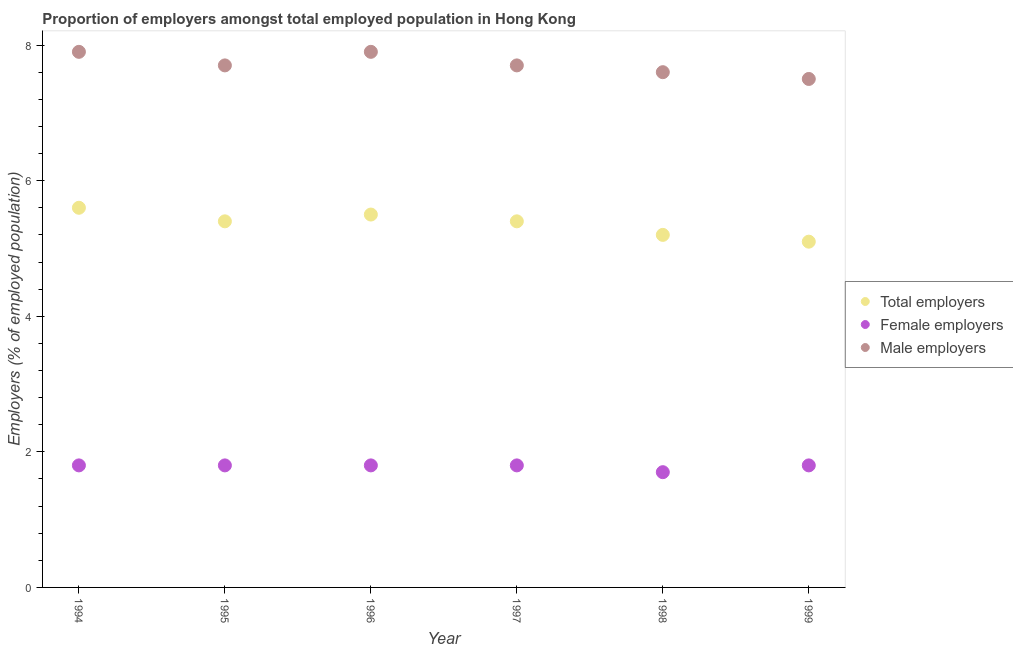How many different coloured dotlines are there?
Make the answer very short. 3. Is the number of dotlines equal to the number of legend labels?
Give a very brief answer. Yes. What is the percentage of male employers in 1997?
Your response must be concise. 7.7. Across all years, what is the maximum percentage of total employers?
Your answer should be compact. 5.6. What is the total percentage of female employers in the graph?
Give a very brief answer. 10.7. What is the difference between the percentage of total employers in 1995 and that in 1996?
Your response must be concise. -0.1. What is the difference between the percentage of male employers in 1994 and the percentage of total employers in 1996?
Your answer should be very brief. 2.4. What is the average percentage of total employers per year?
Give a very brief answer. 5.37. In the year 1994, what is the difference between the percentage of female employers and percentage of total employers?
Offer a very short reply. -3.8. In how many years, is the percentage of female employers greater than 0.8 %?
Keep it short and to the point. 6. What is the ratio of the percentage of female employers in 1998 to that in 1999?
Make the answer very short. 0.94. Is the percentage of total employers in 1994 less than that in 1997?
Provide a succinct answer. No. What is the difference between the highest and the lowest percentage of male employers?
Keep it short and to the point. 0.4. Is it the case that in every year, the sum of the percentage of total employers and percentage of female employers is greater than the percentage of male employers?
Your answer should be very brief. No. Is the percentage of total employers strictly less than the percentage of male employers over the years?
Give a very brief answer. Yes. How many dotlines are there?
Offer a terse response. 3. How many years are there in the graph?
Ensure brevity in your answer.  6. Are the values on the major ticks of Y-axis written in scientific E-notation?
Your response must be concise. No. Does the graph contain any zero values?
Give a very brief answer. No. How many legend labels are there?
Your answer should be very brief. 3. How are the legend labels stacked?
Ensure brevity in your answer.  Vertical. What is the title of the graph?
Provide a succinct answer. Proportion of employers amongst total employed population in Hong Kong. Does "Coal sources" appear as one of the legend labels in the graph?
Offer a terse response. No. What is the label or title of the Y-axis?
Give a very brief answer. Employers (% of employed population). What is the Employers (% of employed population) in Total employers in 1994?
Keep it short and to the point. 5.6. What is the Employers (% of employed population) of Female employers in 1994?
Offer a very short reply. 1.8. What is the Employers (% of employed population) of Male employers in 1994?
Your answer should be very brief. 7.9. What is the Employers (% of employed population) of Total employers in 1995?
Ensure brevity in your answer.  5.4. What is the Employers (% of employed population) of Female employers in 1995?
Provide a succinct answer. 1.8. What is the Employers (% of employed population) in Male employers in 1995?
Provide a succinct answer. 7.7. What is the Employers (% of employed population) of Total employers in 1996?
Provide a short and direct response. 5.5. What is the Employers (% of employed population) of Female employers in 1996?
Ensure brevity in your answer.  1.8. What is the Employers (% of employed population) of Male employers in 1996?
Keep it short and to the point. 7.9. What is the Employers (% of employed population) of Total employers in 1997?
Provide a succinct answer. 5.4. What is the Employers (% of employed population) in Female employers in 1997?
Your answer should be compact. 1.8. What is the Employers (% of employed population) in Male employers in 1997?
Give a very brief answer. 7.7. What is the Employers (% of employed population) of Total employers in 1998?
Your answer should be very brief. 5.2. What is the Employers (% of employed population) of Female employers in 1998?
Provide a succinct answer. 1.7. What is the Employers (% of employed population) in Male employers in 1998?
Give a very brief answer. 7.6. What is the Employers (% of employed population) in Total employers in 1999?
Give a very brief answer. 5.1. What is the Employers (% of employed population) in Female employers in 1999?
Make the answer very short. 1.8. Across all years, what is the maximum Employers (% of employed population) of Total employers?
Ensure brevity in your answer.  5.6. Across all years, what is the maximum Employers (% of employed population) of Female employers?
Make the answer very short. 1.8. Across all years, what is the maximum Employers (% of employed population) in Male employers?
Your response must be concise. 7.9. Across all years, what is the minimum Employers (% of employed population) of Total employers?
Your response must be concise. 5.1. Across all years, what is the minimum Employers (% of employed population) in Female employers?
Offer a terse response. 1.7. What is the total Employers (% of employed population) in Total employers in the graph?
Give a very brief answer. 32.2. What is the total Employers (% of employed population) of Male employers in the graph?
Offer a very short reply. 46.3. What is the difference between the Employers (% of employed population) in Total employers in 1994 and that in 1995?
Offer a very short reply. 0.2. What is the difference between the Employers (% of employed population) of Male employers in 1994 and that in 1995?
Your response must be concise. 0.2. What is the difference between the Employers (% of employed population) in Female employers in 1994 and that in 1997?
Make the answer very short. 0. What is the difference between the Employers (% of employed population) of Male employers in 1994 and that in 1997?
Offer a very short reply. 0.2. What is the difference between the Employers (% of employed population) in Total employers in 1994 and that in 1998?
Give a very brief answer. 0.4. What is the difference between the Employers (% of employed population) of Total employers in 1994 and that in 1999?
Offer a very short reply. 0.5. What is the difference between the Employers (% of employed population) of Female employers in 1994 and that in 1999?
Ensure brevity in your answer.  0. What is the difference between the Employers (% of employed population) of Female employers in 1995 and that in 1997?
Your response must be concise. 0. What is the difference between the Employers (% of employed population) of Total employers in 1995 and that in 1998?
Keep it short and to the point. 0.2. What is the difference between the Employers (% of employed population) in Total employers in 1995 and that in 1999?
Provide a short and direct response. 0.3. What is the difference between the Employers (% of employed population) in Male employers in 1995 and that in 1999?
Keep it short and to the point. 0.2. What is the difference between the Employers (% of employed population) in Total employers in 1996 and that in 1997?
Your response must be concise. 0.1. What is the difference between the Employers (% of employed population) in Total employers in 1996 and that in 1998?
Keep it short and to the point. 0.3. What is the difference between the Employers (% of employed population) of Female employers in 1996 and that in 1998?
Provide a short and direct response. 0.1. What is the difference between the Employers (% of employed population) of Male employers in 1996 and that in 1998?
Provide a short and direct response. 0.3. What is the difference between the Employers (% of employed population) of Total employers in 1996 and that in 1999?
Keep it short and to the point. 0.4. What is the difference between the Employers (% of employed population) of Male employers in 1996 and that in 1999?
Provide a short and direct response. 0.4. What is the difference between the Employers (% of employed population) of Total employers in 1997 and that in 1998?
Offer a very short reply. 0.2. What is the difference between the Employers (% of employed population) in Male employers in 1997 and that in 1998?
Provide a succinct answer. 0.1. What is the difference between the Employers (% of employed population) of Male employers in 1997 and that in 1999?
Provide a succinct answer. 0.2. What is the difference between the Employers (% of employed population) of Total employers in 1998 and that in 1999?
Give a very brief answer. 0.1. What is the difference between the Employers (% of employed population) of Total employers in 1994 and the Employers (% of employed population) of Female employers in 1995?
Your answer should be compact. 3.8. What is the difference between the Employers (% of employed population) of Female employers in 1994 and the Employers (% of employed population) of Male employers in 1995?
Your answer should be compact. -5.9. What is the difference between the Employers (% of employed population) of Total employers in 1994 and the Employers (% of employed population) of Female employers in 1996?
Ensure brevity in your answer.  3.8. What is the difference between the Employers (% of employed population) in Female employers in 1994 and the Employers (% of employed population) in Male employers in 1996?
Your answer should be compact. -6.1. What is the difference between the Employers (% of employed population) in Total employers in 1994 and the Employers (% of employed population) in Female employers in 1997?
Keep it short and to the point. 3.8. What is the difference between the Employers (% of employed population) in Total employers in 1994 and the Employers (% of employed population) in Female employers in 1998?
Offer a terse response. 3.9. What is the difference between the Employers (% of employed population) in Total employers in 1994 and the Employers (% of employed population) in Male employers in 1999?
Give a very brief answer. -1.9. What is the difference between the Employers (% of employed population) of Female employers in 1994 and the Employers (% of employed population) of Male employers in 1999?
Keep it short and to the point. -5.7. What is the difference between the Employers (% of employed population) of Female employers in 1995 and the Employers (% of employed population) of Male employers in 1996?
Keep it short and to the point. -6.1. What is the difference between the Employers (% of employed population) in Female employers in 1995 and the Employers (% of employed population) in Male employers in 1998?
Your response must be concise. -5.8. What is the difference between the Employers (% of employed population) in Total employers in 1996 and the Employers (% of employed population) in Female employers in 1997?
Offer a very short reply. 3.7. What is the difference between the Employers (% of employed population) in Total employers in 1996 and the Employers (% of employed population) in Male employers in 1997?
Your answer should be very brief. -2.2. What is the difference between the Employers (% of employed population) in Female employers in 1996 and the Employers (% of employed population) in Male employers in 1997?
Offer a terse response. -5.9. What is the difference between the Employers (% of employed population) of Total employers in 1996 and the Employers (% of employed population) of Female employers in 1999?
Your answer should be compact. 3.7. What is the difference between the Employers (% of employed population) of Female employers in 1996 and the Employers (% of employed population) of Male employers in 1999?
Provide a short and direct response. -5.7. What is the difference between the Employers (% of employed population) in Total employers in 1997 and the Employers (% of employed population) in Female employers in 1998?
Your response must be concise. 3.7. What is the difference between the Employers (% of employed population) in Female employers in 1997 and the Employers (% of employed population) in Male employers in 1998?
Your answer should be very brief. -5.8. What is the difference between the Employers (% of employed population) of Total employers in 1997 and the Employers (% of employed population) of Male employers in 1999?
Your answer should be very brief. -2.1. What is the difference between the Employers (% of employed population) in Female employers in 1997 and the Employers (% of employed population) in Male employers in 1999?
Your response must be concise. -5.7. What is the average Employers (% of employed population) in Total employers per year?
Your answer should be very brief. 5.37. What is the average Employers (% of employed population) of Female employers per year?
Keep it short and to the point. 1.78. What is the average Employers (% of employed population) of Male employers per year?
Your response must be concise. 7.72. In the year 1994, what is the difference between the Employers (% of employed population) in Total employers and Employers (% of employed population) in Male employers?
Make the answer very short. -2.3. In the year 1995, what is the difference between the Employers (% of employed population) of Total employers and Employers (% of employed population) of Female employers?
Offer a terse response. 3.6. In the year 1995, what is the difference between the Employers (% of employed population) in Total employers and Employers (% of employed population) in Male employers?
Your answer should be compact. -2.3. In the year 1996, what is the difference between the Employers (% of employed population) of Total employers and Employers (% of employed population) of Male employers?
Make the answer very short. -2.4. In the year 1996, what is the difference between the Employers (% of employed population) in Female employers and Employers (% of employed population) in Male employers?
Keep it short and to the point. -6.1. In the year 1997, what is the difference between the Employers (% of employed population) in Total employers and Employers (% of employed population) in Female employers?
Your answer should be very brief. 3.6. In the year 1998, what is the difference between the Employers (% of employed population) of Total employers and Employers (% of employed population) of Female employers?
Your response must be concise. 3.5. In the year 1999, what is the difference between the Employers (% of employed population) of Total employers and Employers (% of employed population) of Female employers?
Your answer should be very brief. 3.3. In the year 1999, what is the difference between the Employers (% of employed population) in Total employers and Employers (% of employed population) in Male employers?
Give a very brief answer. -2.4. What is the ratio of the Employers (% of employed population) of Total employers in 1994 to that in 1995?
Your response must be concise. 1.04. What is the ratio of the Employers (% of employed population) of Total employers in 1994 to that in 1996?
Keep it short and to the point. 1.02. What is the ratio of the Employers (% of employed population) of Male employers in 1994 to that in 1997?
Your answer should be very brief. 1.03. What is the ratio of the Employers (% of employed population) of Total employers in 1994 to that in 1998?
Your answer should be compact. 1.08. What is the ratio of the Employers (% of employed population) of Female employers in 1994 to that in 1998?
Offer a terse response. 1.06. What is the ratio of the Employers (% of employed population) in Male employers in 1994 to that in 1998?
Offer a very short reply. 1.04. What is the ratio of the Employers (% of employed population) of Total employers in 1994 to that in 1999?
Provide a short and direct response. 1.1. What is the ratio of the Employers (% of employed population) in Male employers in 1994 to that in 1999?
Your answer should be very brief. 1.05. What is the ratio of the Employers (% of employed population) of Total employers in 1995 to that in 1996?
Offer a very short reply. 0.98. What is the ratio of the Employers (% of employed population) in Female employers in 1995 to that in 1996?
Your answer should be very brief. 1. What is the ratio of the Employers (% of employed population) of Male employers in 1995 to that in 1996?
Make the answer very short. 0.97. What is the ratio of the Employers (% of employed population) in Total employers in 1995 to that in 1997?
Offer a terse response. 1. What is the ratio of the Employers (% of employed population) in Male employers in 1995 to that in 1997?
Provide a succinct answer. 1. What is the ratio of the Employers (% of employed population) in Female employers in 1995 to that in 1998?
Offer a terse response. 1.06. What is the ratio of the Employers (% of employed population) in Male employers in 1995 to that in 1998?
Keep it short and to the point. 1.01. What is the ratio of the Employers (% of employed population) in Total employers in 1995 to that in 1999?
Offer a terse response. 1.06. What is the ratio of the Employers (% of employed population) in Female employers in 1995 to that in 1999?
Give a very brief answer. 1. What is the ratio of the Employers (% of employed population) of Male employers in 1995 to that in 1999?
Keep it short and to the point. 1.03. What is the ratio of the Employers (% of employed population) in Total employers in 1996 to that in 1997?
Your response must be concise. 1.02. What is the ratio of the Employers (% of employed population) of Female employers in 1996 to that in 1997?
Your response must be concise. 1. What is the ratio of the Employers (% of employed population) in Total employers in 1996 to that in 1998?
Your response must be concise. 1.06. What is the ratio of the Employers (% of employed population) in Female employers in 1996 to that in 1998?
Give a very brief answer. 1.06. What is the ratio of the Employers (% of employed population) in Male employers in 1996 to that in 1998?
Offer a terse response. 1.04. What is the ratio of the Employers (% of employed population) of Total employers in 1996 to that in 1999?
Your response must be concise. 1.08. What is the ratio of the Employers (% of employed population) in Male employers in 1996 to that in 1999?
Your response must be concise. 1.05. What is the ratio of the Employers (% of employed population) of Total employers in 1997 to that in 1998?
Make the answer very short. 1.04. What is the ratio of the Employers (% of employed population) in Female employers in 1997 to that in 1998?
Offer a very short reply. 1.06. What is the ratio of the Employers (% of employed population) of Male employers in 1997 to that in 1998?
Provide a succinct answer. 1.01. What is the ratio of the Employers (% of employed population) of Total employers in 1997 to that in 1999?
Your answer should be very brief. 1.06. What is the ratio of the Employers (% of employed population) in Female employers in 1997 to that in 1999?
Offer a terse response. 1. What is the ratio of the Employers (% of employed population) of Male employers in 1997 to that in 1999?
Offer a very short reply. 1.03. What is the ratio of the Employers (% of employed population) of Total employers in 1998 to that in 1999?
Keep it short and to the point. 1.02. What is the ratio of the Employers (% of employed population) of Male employers in 1998 to that in 1999?
Provide a short and direct response. 1.01. What is the difference between the highest and the second highest Employers (% of employed population) in Female employers?
Your answer should be compact. 0. What is the difference between the highest and the second highest Employers (% of employed population) in Male employers?
Provide a succinct answer. 0. What is the difference between the highest and the lowest Employers (% of employed population) of Male employers?
Give a very brief answer. 0.4. 